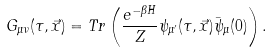Convert formula to latex. <formula><loc_0><loc_0><loc_500><loc_500>G _ { \mu \nu } ( \tau , \vec { x } ) = T r \left ( \frac { e ^ { - \beta H } } { Z } \psi _ { \mu ^ { \prime } } ( \tau , \vec { x } ) \bar { \psi } _ { \mu } ( 0 ) \right ) .</formula> 